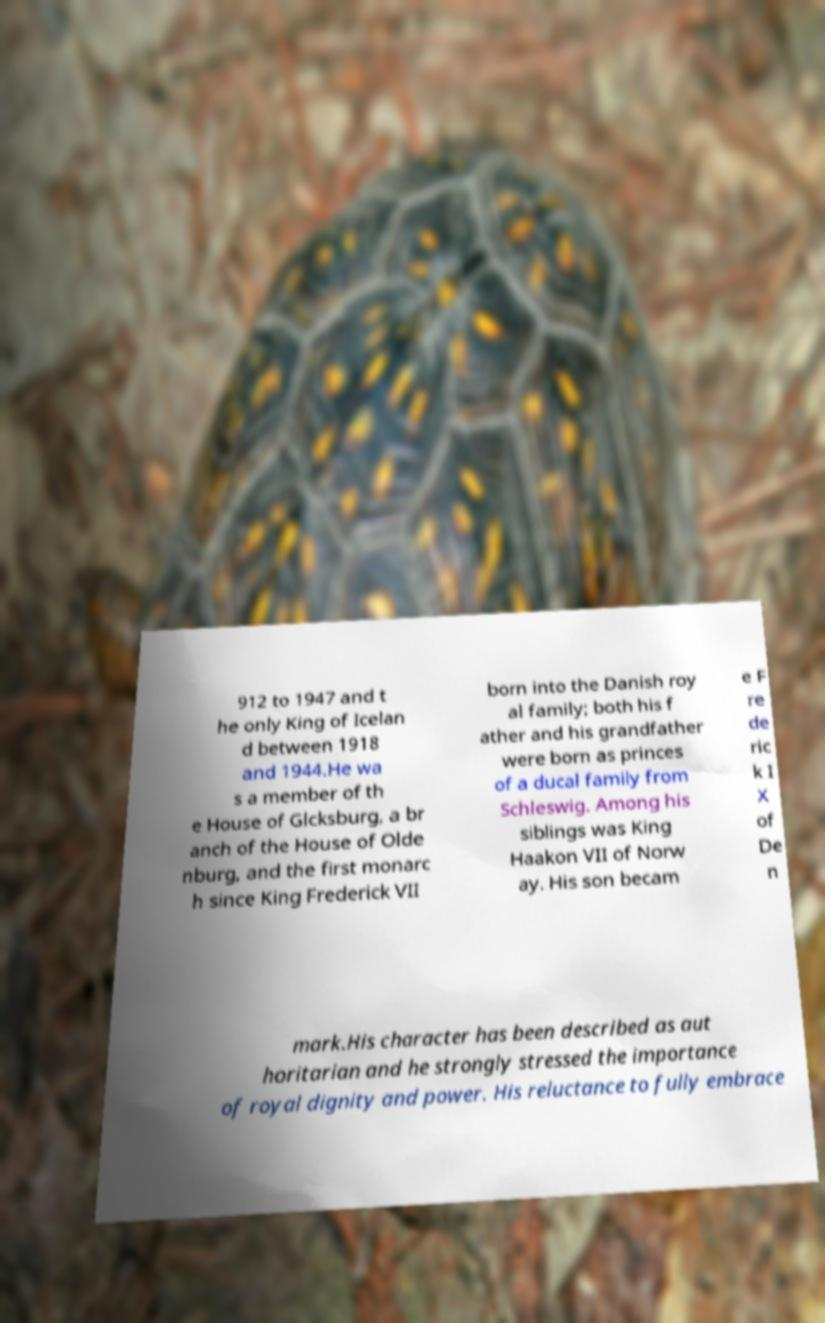There's text embedded in this image that I need extracted. Can you transcribe it verbatim? 912 to 1947 and t he only King of Icelan d between 1918 and 1944.He wa s a member of th e House of Glcksburg, a br anch of the House of Olde nburg, and the first monarc h since King Frederick VII born into the Danish roy al family; both his f ather and his grandfather were born as princes of a ducal family from Schleswig. Among his siblings was King Haakon VII of Norw ay. His son becam e F re de ric k I X of De n mark.His character has been described as aut horitarian and he strongly stressed the importance of royal dignity and power. His reluctance to fully embrace 